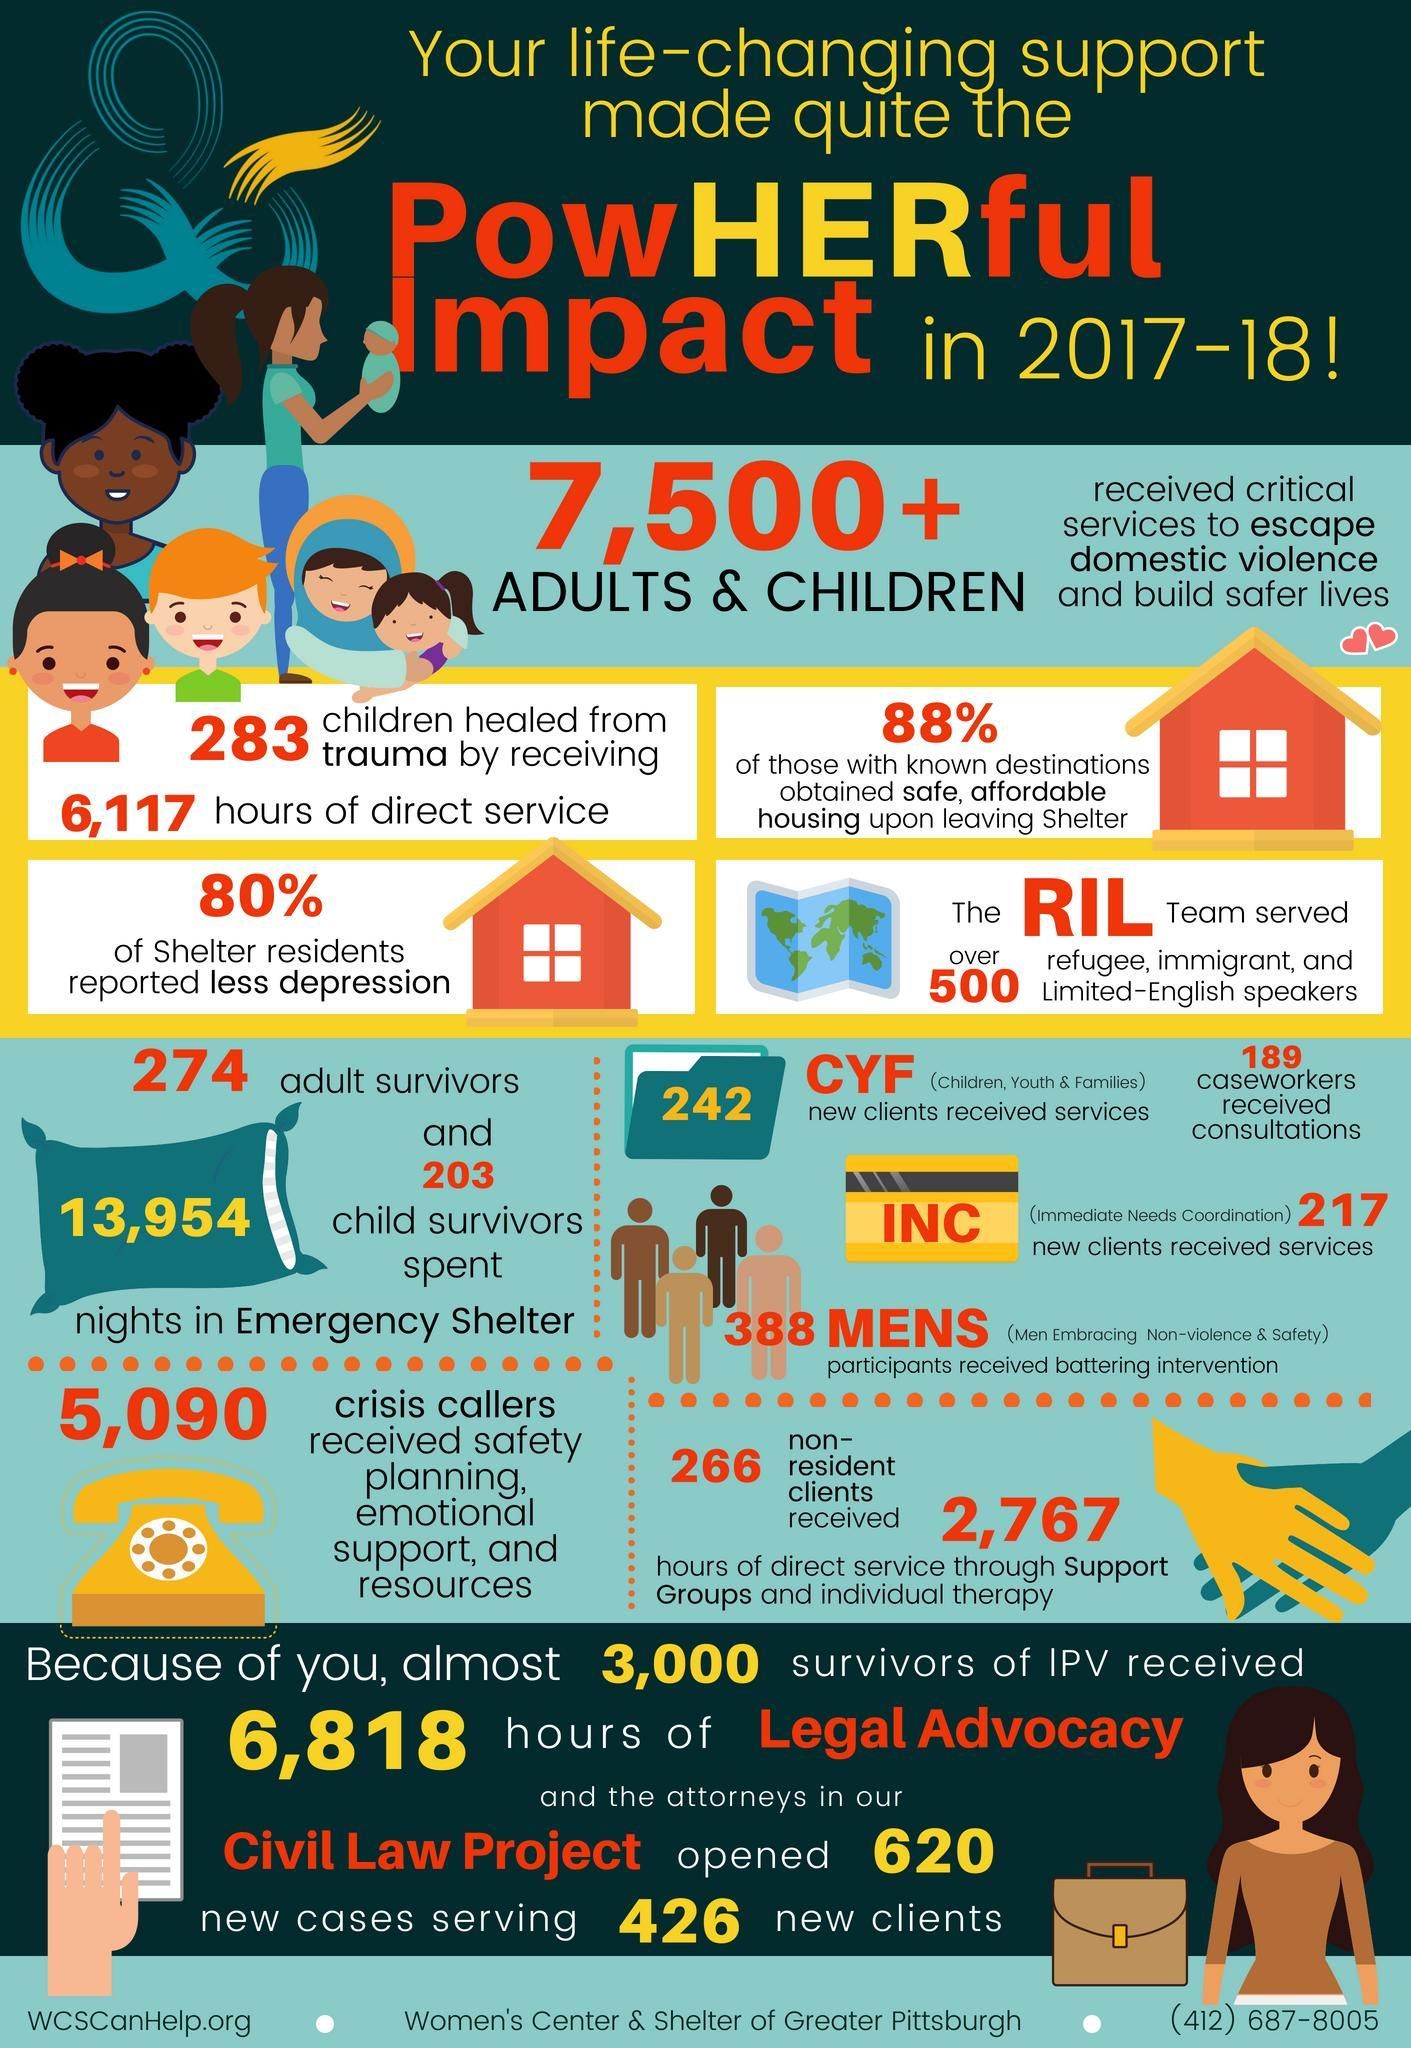How many nights did were spent by the adult and child survivors in shelters during crisis, 274, 242, 203, or 13,954?
Answer the question with a short phrase. 13,954 What was is the total of new clients and non-resident clients received? 508 How many hours of service was provided through support groups, 5090, 266, or 2767? 2,767 